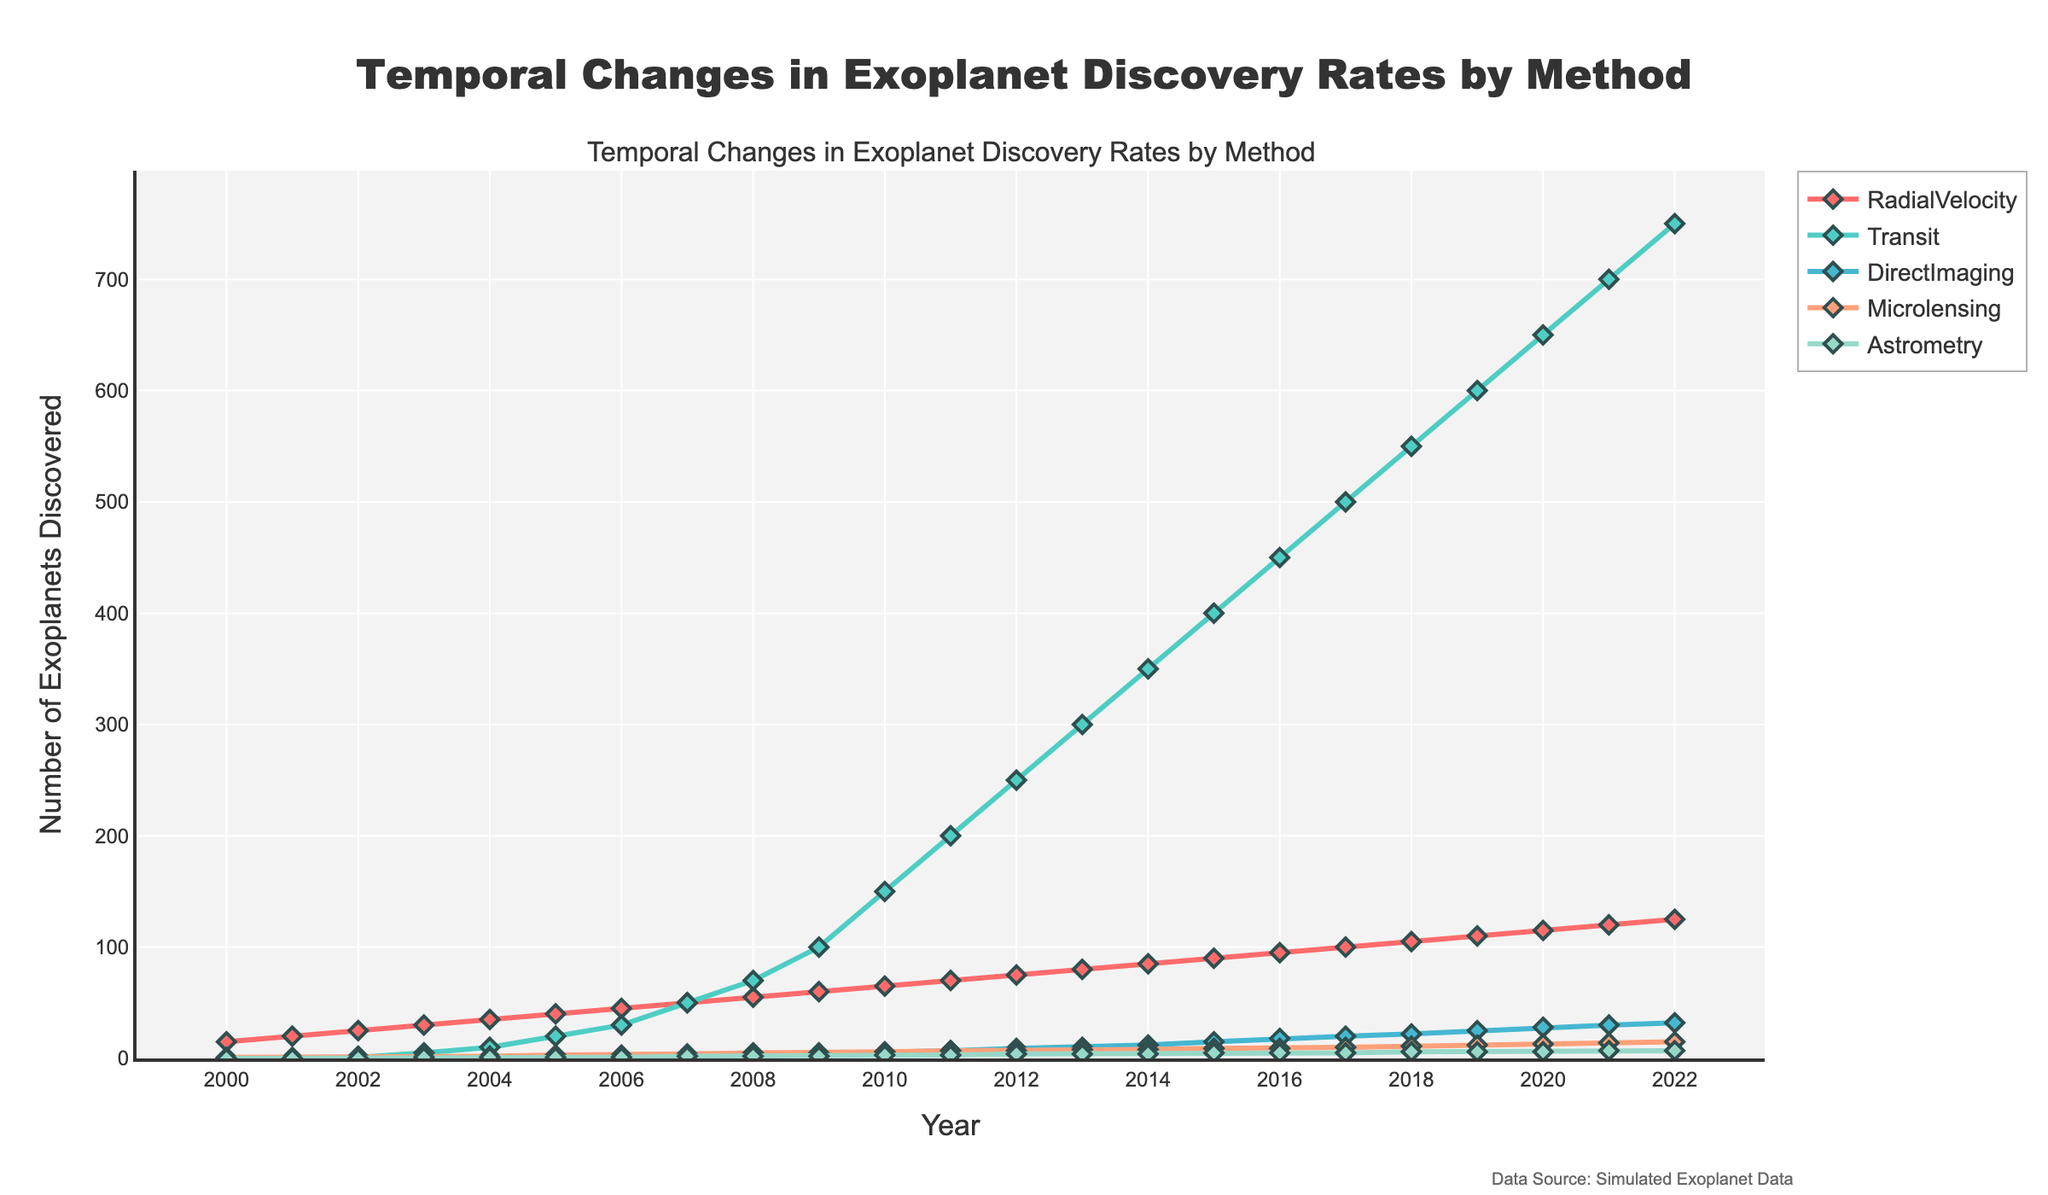what is the title of the plot? The title is usually located at the top center of the plot and is designed to summarize the main point or theme of the data visualization. In this case, the title is explicitly specified in the plot creation code.
Answer: Temporal Changes in Exoplanet Discovery Rates by Method what does the y-axis represent? The y-axis is the vertical axis on the plot and it is typically labeled to show what it represents. Here, the y-axis is labeled as "Number of Exoplanets Discovered," indicating that it measures the quantity of exoplanets found.
Answer: Number of Exoplanets Discovered what color is used for the "Transit" method? The colors used for each method are defined in the custom color palette. In this case, "#4ECDC4" corresponds to light teal or turquoise, which is assigned to the "Transit" method.
Answer: Light teal or turquoise How many exoplanets were discovered by Microlensing in 2010? To find the answer, look at the year 2010 on the x-axis and find the corresponding point for the "Microlensing" method. According to the data, the number of exoplanets discovered by microlensing in 2010 is 6.
Answer: 6 Which method shows the highest discovery rate in 2022? Examine the data points for each method in the year 2022 on the x-axis. Compare the values on the y-axis to see which is the highest. The "Transit" method has the highest discovery rate of 750 exoplanets in 2022.
Answer: Transit Identify the year when the number of exoplanets discovered by "RadialVelocity" first surpassed 50. To solve this, examine the data points for the "RadialVelocity" method and identify the first year when its value on the y-axis exceeds 50. This happens in the year 2007.
Answer: 2007 how many total exoplanets were discovered using all methods in 2005? Sum up the values for all the discovery methods in the year 2005. RadialVelocity: 40, Transit: 20, DirectImaging: 1, Microlensing: 3, Astrometry: 1. Total = 40 + 20 + 1 + 3 + 1 = 65
Answer: 65 Between 2010 and 2020, which method had the highest increase in the number of exoplanet discoveries? To determine this, calculate the difference in the number of exoplanets discovered in 2010 and 2020 for each method and compare the increases. The "Transit" method increased from 150 in 2010 to 650 in 2020, an increase of 500.
Answer: Transit which discovery method had the least number of exoplanets discovered in 2015? Inspect the data points for 2015 and find the method with the lowest value on the y-axis. The "Astrometry" method had the least number of exoplanets discovered with a value of 5.
Answer: Astrometry Do discovery rates increase or decrease over time for the "DirectImaging" method? Examine the trend line for the "DirectImaging" method from 2000 to 2022. The values generally increase over time, indicating a positive trend in discovery rates.
Answer: Increase 